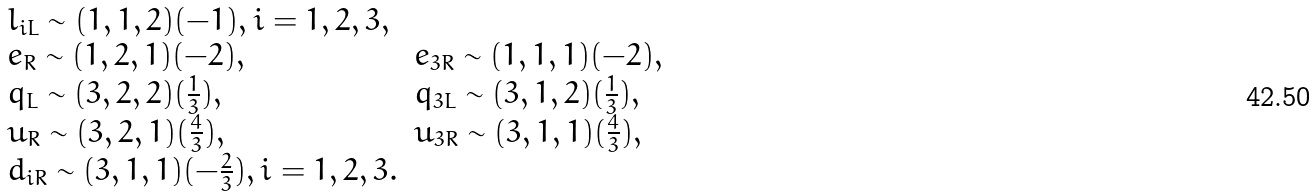Convert formula to latex. <formula><loc_0><loc_0><loc_500><loc_500>\begin{array} { l l } l _ { i L } \sim ( 1 , 1 , 2 ) ( - 1 ) , i = 1 , 2 , 3 , & \\ e _ { R } \sim ( 1 , 2 , 1 ) ( - 2 ) , & e _ { 3 R } \sim ( 1 , 1 , 1 ) ( - 2 ) , \\ q _ { L } \sim ( 3 , 2 , 2 ) ( \frac { 1 } { 3 } ) , & q _ { 3 L } \sim ( 3 , 1 , 2 ) ( \frac { 1 } { 3 } ) , \\ u _ { R } \sim ( 3 , 2 , 1 ) ( \frac { 4 } { 3 } ) , & u _ { 3 R } \sim ( 3 , 1 , 1 ) ( \frac { 4 } { 3 } ) , \\ d _ { i R } \sim ( 3 , 1 , 1 ) ( - \frac { 2 } { 3 } ) , i = 1 , 2 , 3 . & \end{array}</formula> 